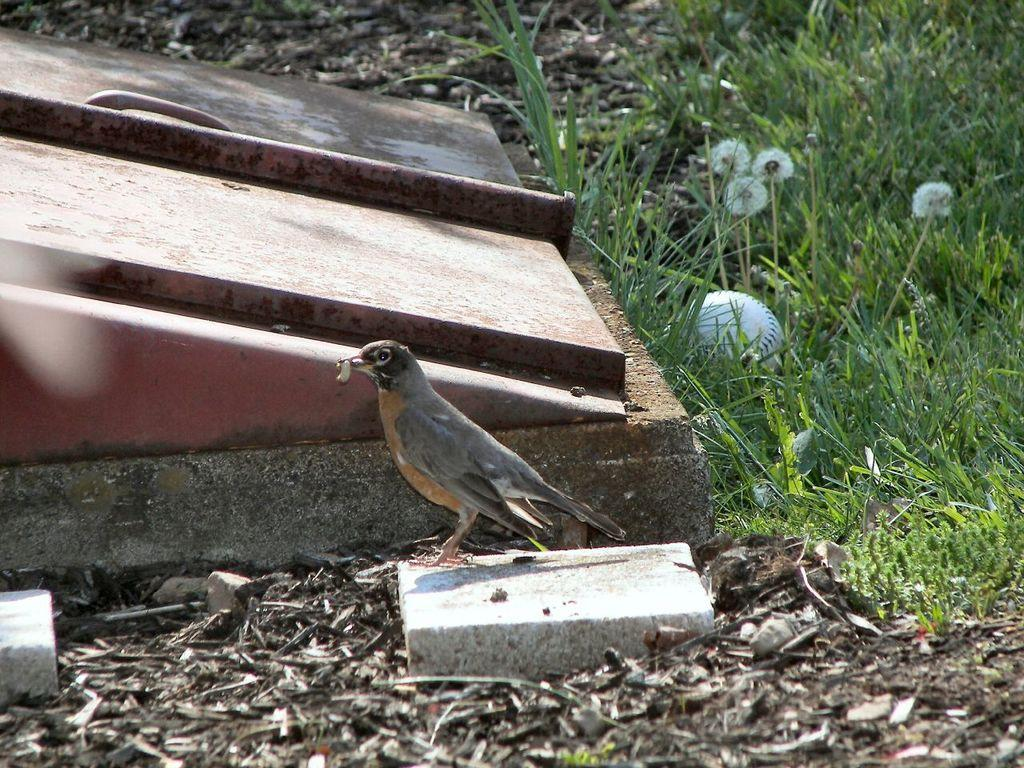What type of animal is in the image? There is a bird in the image. What is the bird doing in the image? The bird is holding an object in its mouth. Can you describe the background of the image? There are objects, a handle, grass, and flowers visible in the background. What color is the ball in the image? The ball in the image is white. Can you tell me how many goats are present in the image? There are no goats present in the image; it features a bird holding an object in its mouth. What does the bird believe about the self in the image? The image does not provide any information about the bird's beliefs or thoughts, so we cannot determine what the bird believes about the self. 